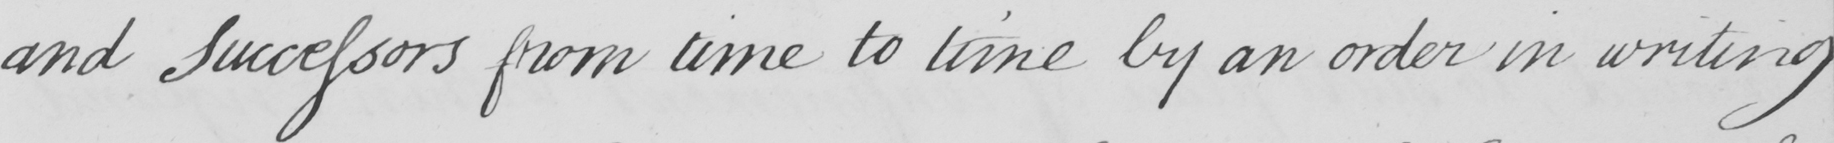What text is written in this handwritten line? and Successors from time to time by an order in writing 